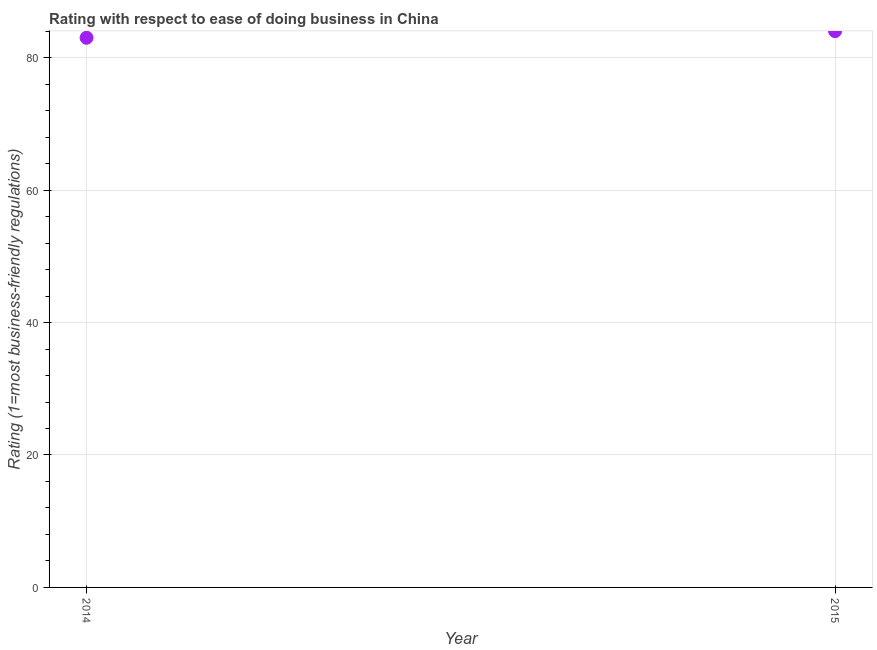What is the ease of doing business index in 2014?
Ensure brevity in your answer.  83. Across all years, what is the maximum ease of doing business index?
Your answer should be compact. 84. Across all years, what is the minimum ease of doing business index?
Your answer should be compact. 83. In which year was the ease of doing business index maximum?
Offer a terse response. 2015. What is the sum of the ease of doing business index?
Your answer should be compact. 167. What is the difference between the ease of doing business index in 2014 and 2015?
Make the answer very short. -1. What is the average ease of doing business index per year?
Offer a very short reply. 83.5. What is the median ease of doing business index?
Your answer should be compact. 83.5. In how many years, is the ease of doing business index greater than 56 ?
Keep it short and to the point. 2. What is the ratio of the ease of doing business index in 2014 to that in 2015?
Your answer should be compact. 0.99. In how many years, is the ease of doing business index greater than the average ease of doing business index taken over all years?
Offer a terse response. 1. Does the ease of doing business index monotonically increase over the years?
Your answer should be compact. Yes. How many dotlines are there?
Provide a succinct answer. 1. How many years are there in the graph?
Your answer should be compact. 2. Does the graph contain any zero values?
Your answer should be very brief. No. What is the title of the graph?
Offer a terse response. Rating with respect to ease of doing business in China. What is the label or title of the Y-axis?
Ensure brevity in your answer.  Rating (1=most business-friendly regulations). What is the Rating (1=most business-friendly regulations) in 2014?
Offer a very short reply. 83. What is the difference between the Rating (1=most business-friendly regulations) in 2014 and 2015?
Offer a very short reply. -1. What is the ratio of the Rating (1=most business-friendly regulations) in 2014 to that in 2015?
Offer a very short reply. 0.99. 